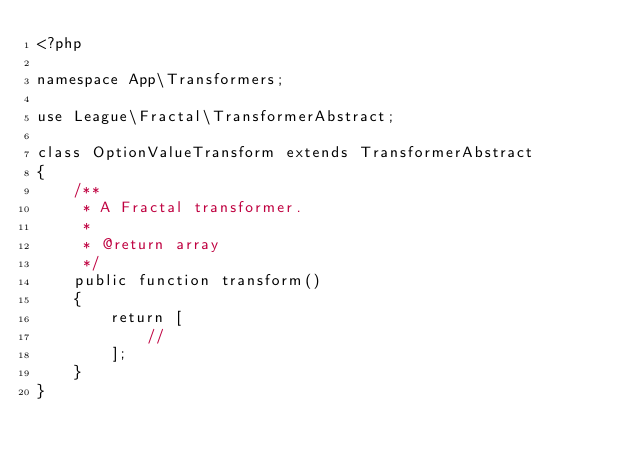Convert code to text. <code><loc_0><loc_0><loc_500><loc_500><_PHP_><?php

namespace App\Transformers;

use League\Fractal\TransformerAbstract;

class OptionValueTransform extends TransformerAbstract
{
    /**
     * A Fractal transformer.
     *
     * @return array
     */
    public function transform()
    {
        return [
            //
        ];
    }
}
</code> 